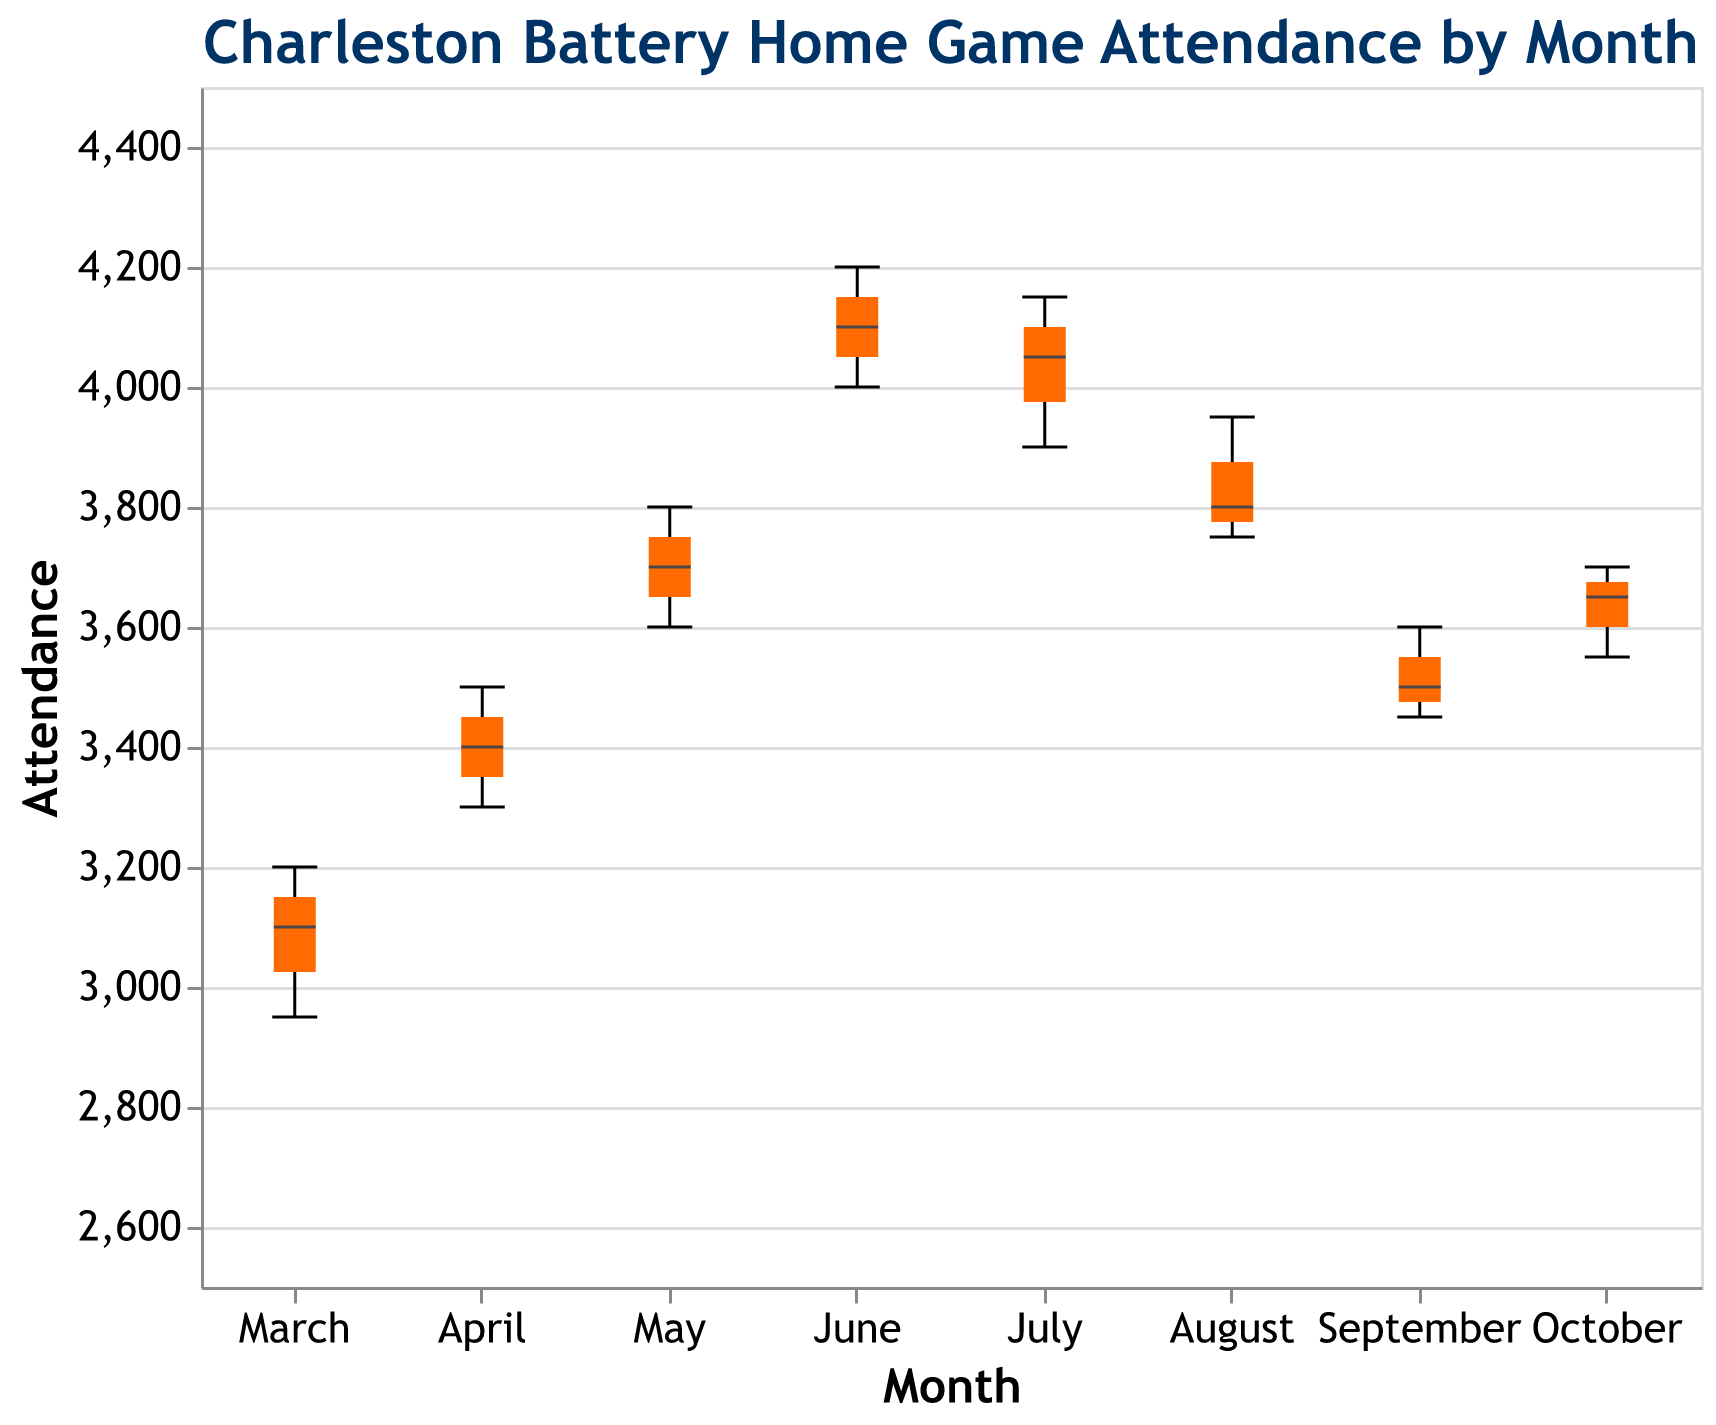How many months are displayed in the plot? The x-axis of the plot shows distinct categories representing months. By counting these categories, we can determine the number of months displayed.
Answer: 8 Which month has the highest median attendance, and what is the value? In a box plot, the median is represented by a line inside the box. By examining each month, we can find the one with the highest median line.
Answer: June, 4100 What is the range of attendance values in August? The range can be determined by finding the lowest and highest points (the whiskers) for August on the y-axis. The range is the difference between these two values.
Answer: 3750 to 3950 In which month is the maximum attendance observed, and what is the value? The maximum attendance is represented by the highest point (top whisker) across all months. We identify the highest point and the corresponding month.
Answer: June, 4200 Compare the median attendance in March and May. Which month has a higher median? The median is represented by the line inside the box for each month. By comparing the position of these lines in March and May, we can determine which is higher.
Answer: May What is the interquartile range (IQR) for July? The IQR is the difference between the upper quartile (top of the box) and the lower quartile (bottom of the box). By measuring these values from the plot, we can calculate the IQR for July.
Answer: 3900 to 4050, IQR = 150 How does the median attendance change from April to June? By noting the position of the median lines for April and June, we can describe how the median attendance value shifts between these months.
Answer: Increases Which month exhibits the least variation in attendance? The variation is indicated by the distance between the top and bottom whiskers. The month with the shortest whiskers distance has the least variation.
Answer: March Identify the month with the lowest median attendance. By comparing the positions of the median lines inside the boxes for each month, we can identify the month with the lowest median.
Answer: March 